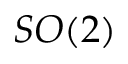<formula> <loc_0><loc_0><loc_500><loc_500>S O ( 2 )</formula> 